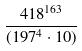Convert formula to latex. <formula><loc_0><loc_0><loc_500><loc_500>\frac { 4 1 8 ^ { 1 6 3 } } { ( 1 9 7 ^ { 4 } \cdot 1 0 ) }</formula> 